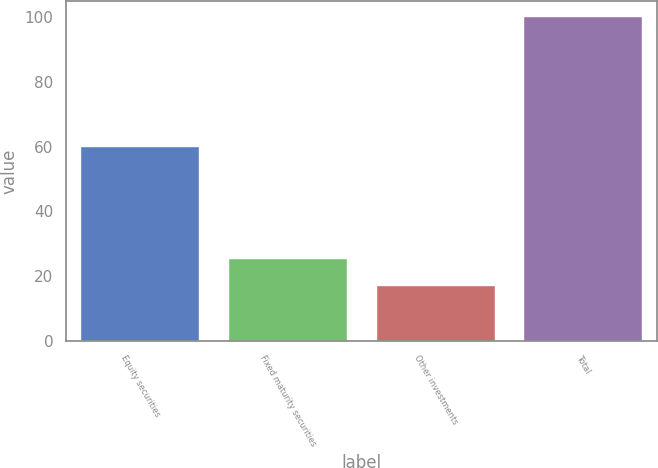Convert chart to OTSL. <chart><loc_0><loc_0><loc_500><loc_500><bar_chart><fcel>Equity securities<fcel>Fixed maturity securities<fcel>Other investments<fcel>Total<nl><fcel>60<fcel>25.3<fcel>17<fcel>100<nl></chart> 